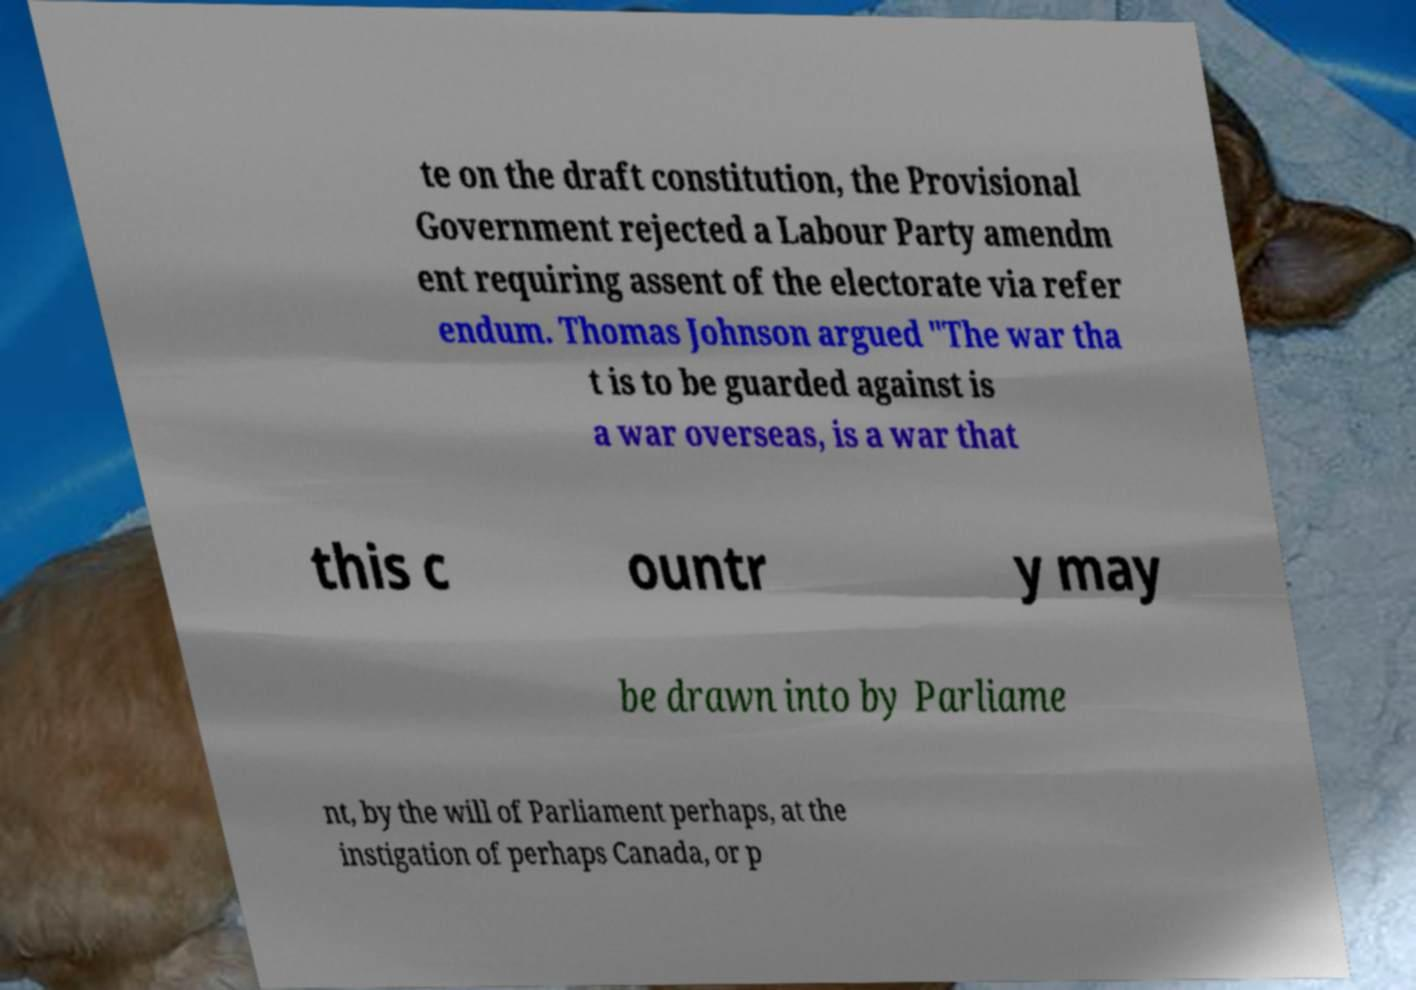For documentation purposes, I need the text within this image transcribed. Could you provide that? te on the draft constitution, the Provisional Government rejected a Labour Party amendm ent requiring assent of the electorate via refer endum. Thomas Johnson argued "The war tha t is to be guarded against is a war overseas, is a war that this c ountr y may be drawn into by Parliame nt, by the will of Parliament perhaps, at the instigation of perhaps Canada, or p 